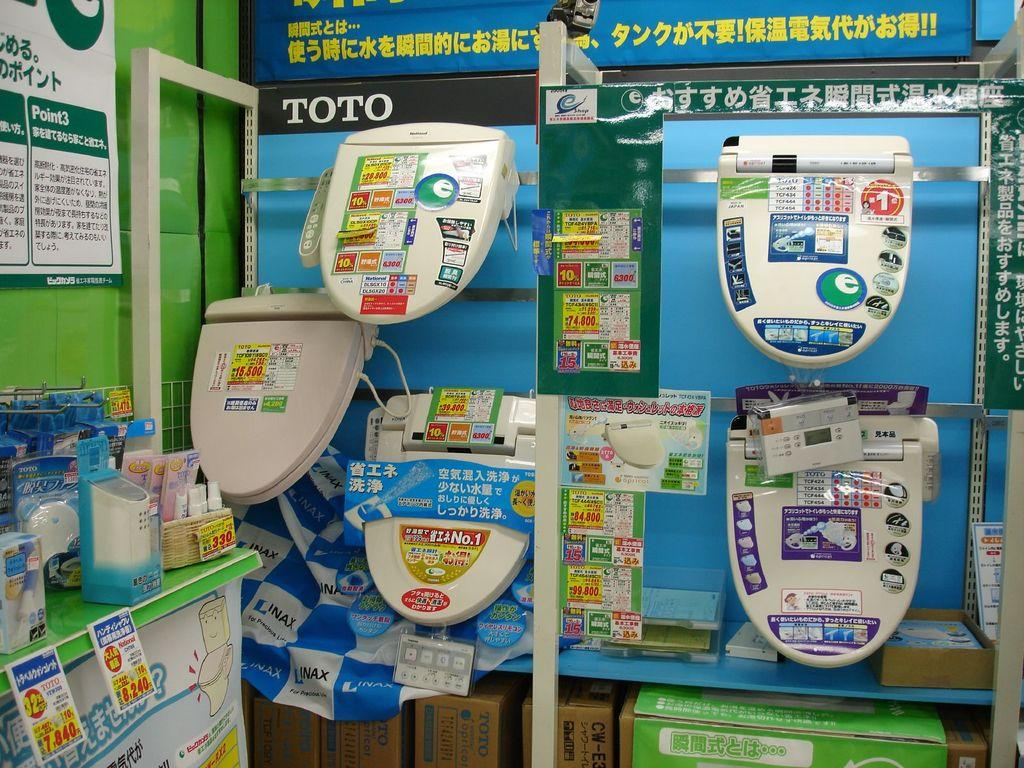<image>
Create a compact narrative representing the image presented. a toilet seat display by TOTO has several seats to look at 